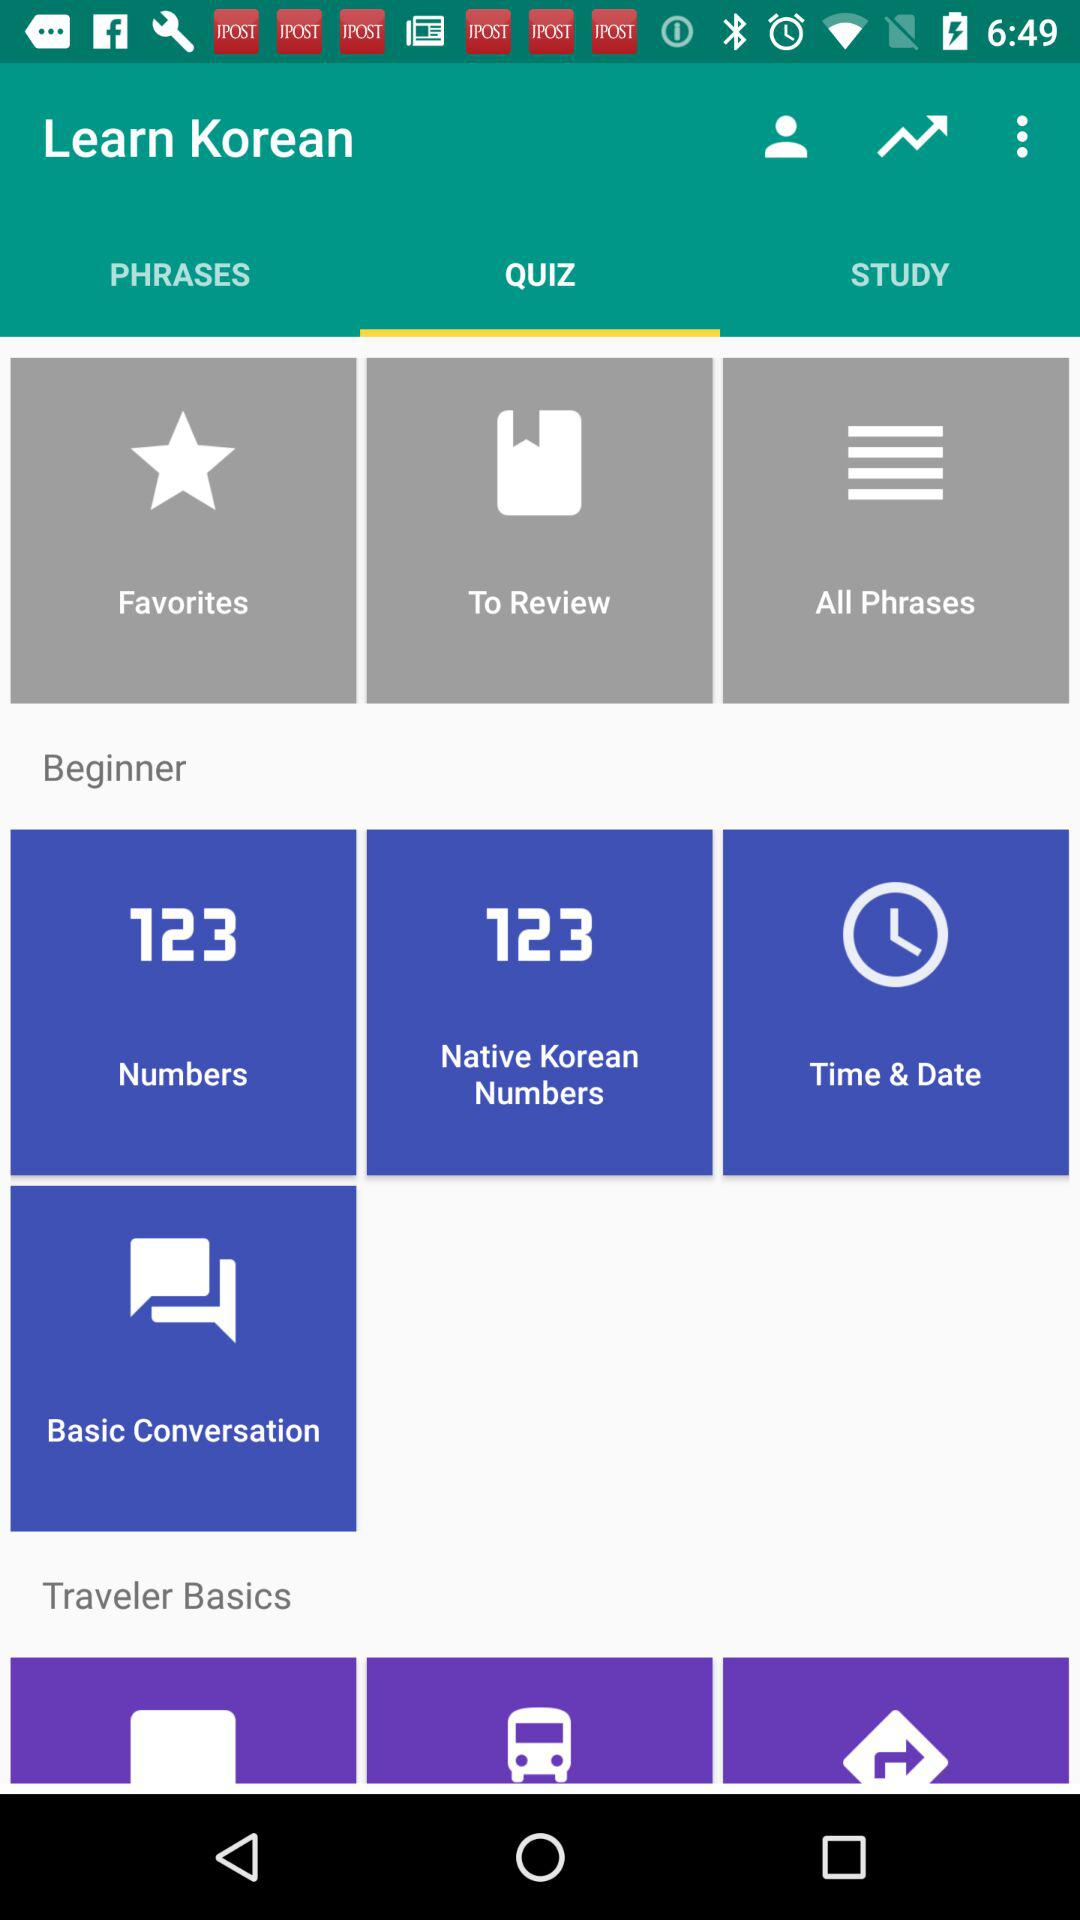Which tab is selected? The selected tab is "QUIZ". 